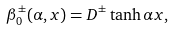<formula> <loc_0><loc_0><loc_500><loc_500>\beta _ { 0 } ^ { \pm } ( \alpha , x ) = D ^ { \pm } \tanh \alpha x ,</formula> 